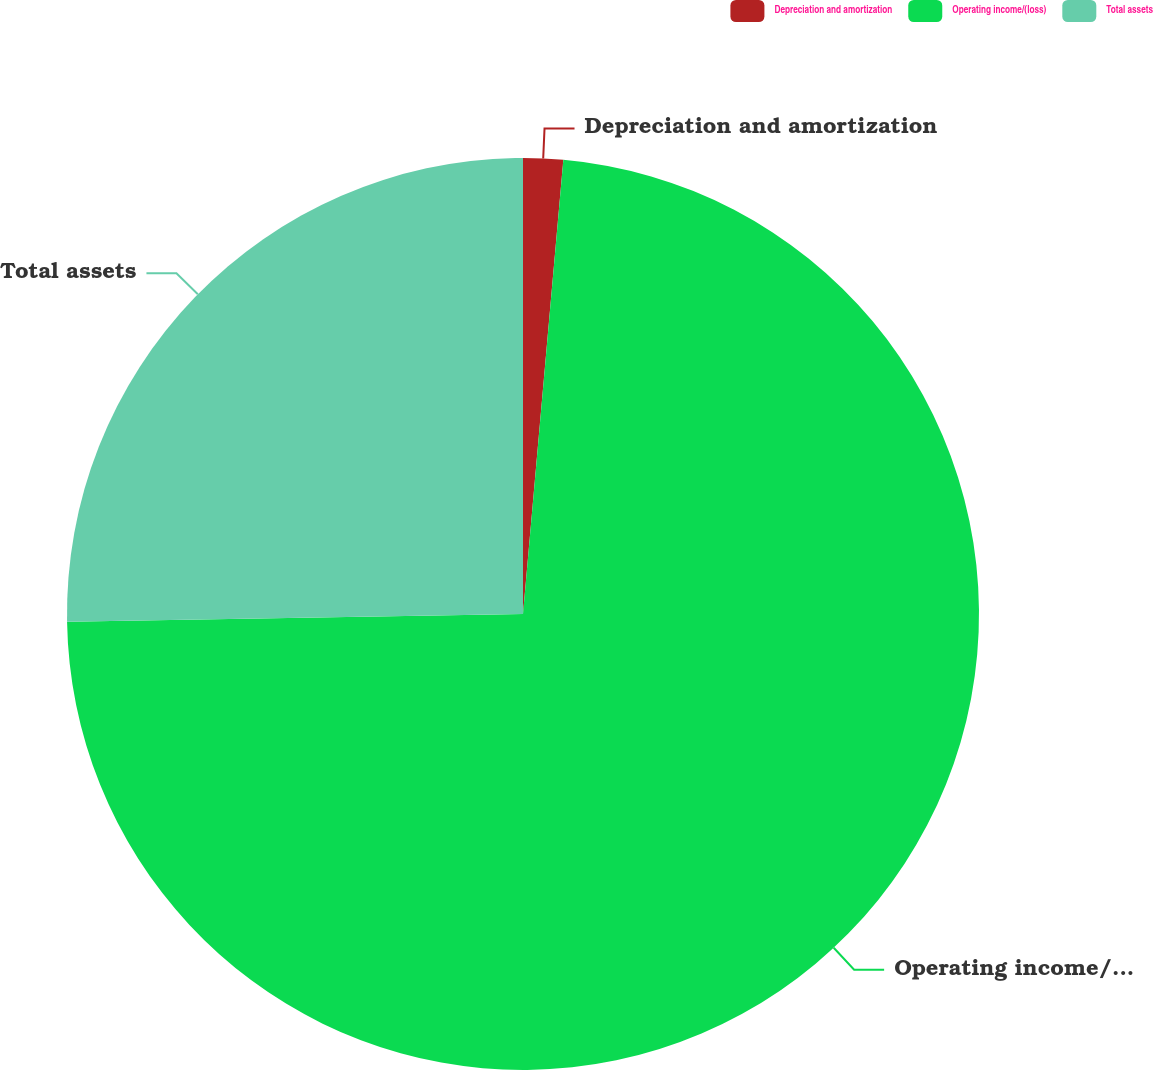Convert chart. <chart><loc_0><loc_0><loc_500><loc_500><pie_chart><fcel>Depreciation and amortization<fcel>Operating income/(loss)<fcel>Total assets<nl><fcel>1.41%<fcel>73.32%<fcel>25.27%<nl></chart> 